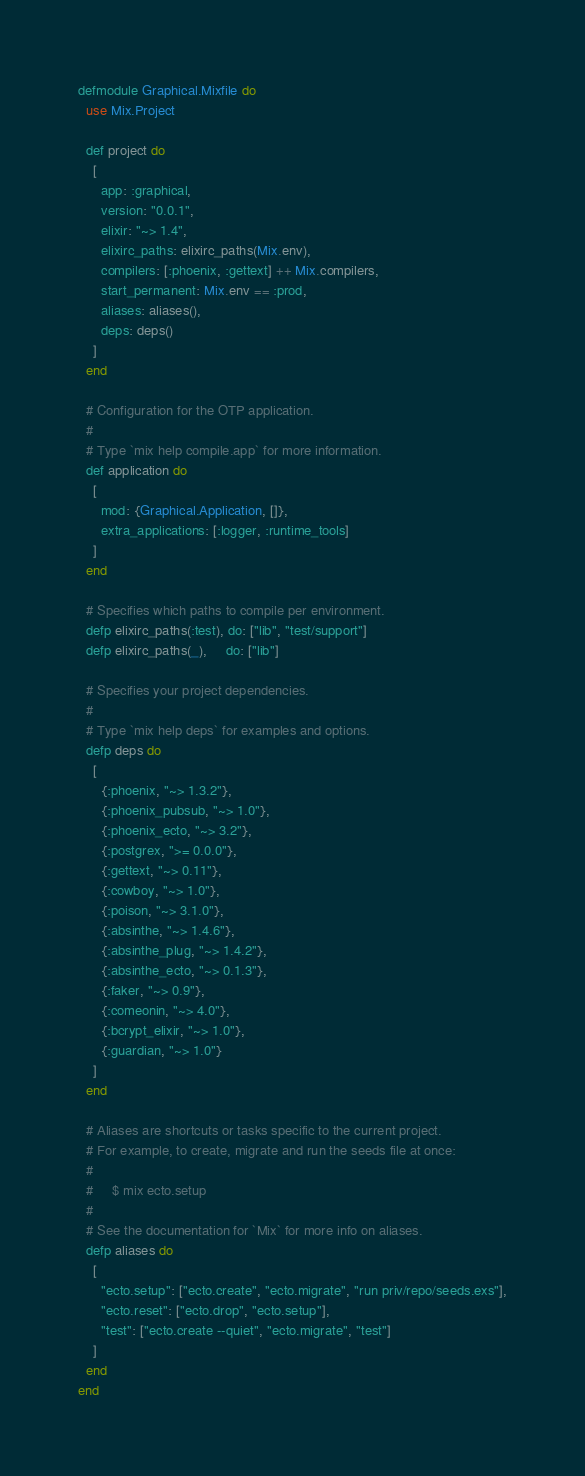Convert code to text. <code><loc_0><loc_0><loc_500><loc_500><_Elixir_>defmodule Graphical.Mixfile do
  use Mix.Project

  def project do
    [
      app: :graphical,
      version: "0.0.1",
      elixir: "~> 1.4",
      elixirc_paths: elixirc_paths(Mix.env),
      compilers: [:phoenix, :gettext] ++ Mix.compilers,
      start_permanent: Mix.env == :prod,
      aliases: aliases(),
      deps: deps()
    ]
  end

  # Configuration for the OTP application.
  #
  # Type `mix help compile.app` for more information.
  def application do
    [
      mod: {Graphical.Application, []},
      extra_applications: [:logger, :runtime_tools]
    ]
  end

  # Specifies which paths to compile per environment.
  defp elixirc_paths(:test), do: ["lib", "test/support"]
  defp elixirc_paths(_),     do: ["lib"]

  # Specifies your project dependencies.
  #
  # Type `mix help deps` for examples and options.
  defp deps do
    [
      {:phoenix, "~> 1.3.2"},
      {:phoenix_pubsub, "~> 1.0"},
      {:phoenix_ecto, "~> 3.2"},
      {:postgrex, ">= 0.0.0"},
      {:gettext, "~> 0.11"},
      {:cowboy, "~> 1.0"},
      {:poison, "~> 3.1.0"},
      {:absinthe, "~> 1.4.6"},
      {:absinthe_plug, "~> 1.4.2"},
      {:absinthe_ecto, "~> 0.1.3"},
      {:faker, "~> 0.9"},
      {:comeonin, "~> 4.0"},
      {:bcrypt_elixir, "~> 1.0"},
      {:guardian, "~> 1.0"}
    ]
  end

  # Aliases are shortcuts or tasks specific to the current project.
  # For example, to create, migrate and run the seeds file at once:
  #
  #     $ mix ecto.setup
  #
  # See the documentation for `Mix` for more info on aliases.
  defp aliases do
    [
      "ecto.setup": ["ecto.create", "ecto.migrate", "run priv/repo/seeds.exs"],
      "ecto.reset": ["ecto.drop", "ecto.setup"],
      "test": ["ecto.create --quiet", "ecto.migrate", "test"]
    ]
  end
end
</code> 